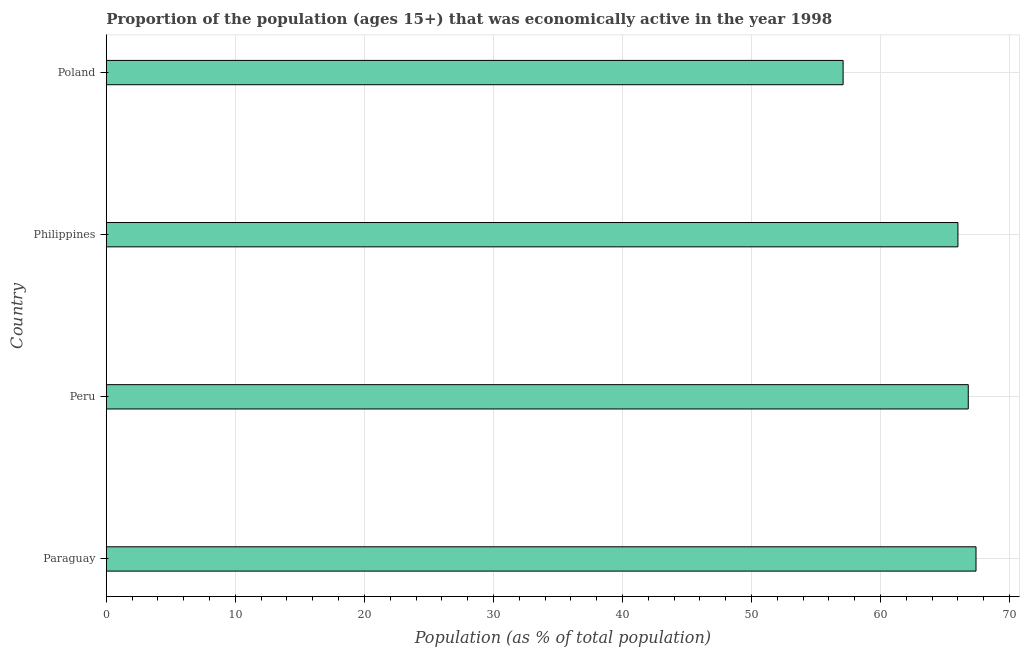Does the graph contain any zero values?
Offer a terse response. No. Does the graph contain grids?
Offer a very short reply. Yes. What is the title of the graph?
Provide a short and direct response. Proportion of the population (ages 15+) that was economically active in the year 1998. What is the label or title of the X-axis?
Offer a very short reply. Population (as % of total population). Across all countries, what is the maximum percentage of economically active population?
Ensure brevity in your answer.  67.4. Across all countries, what is the minimum percentage of economically active population?
Give a very brief answer. 57.1. In which country was the percentage of economically active population maximum?
Ensure brevity in your answer.  Paraguay. What is the sum of the percentage of economically active population?
Offer a terse response. 257.3. What is the average percentage of economically active population per country?
Offer a very short reply. 64.33. What is the median percentage of economically active population?
Your answer should be compact. 66.4. In how many countries, is the percentage of economically active population greater than 62 %?
Give a very brief answer. 3. What is the ratio of the percentage of economically active population in Paraguay to that in Poland?
Give a very brief answer. 1.18. Is the percentage of economically active population in Paraguay less than that in Peru?
Provide a succinct answer. No. Is the difference between the percentage of economically active population in Paraguay and Poland greater than the difference between any two countries?
Provide a short and direct response. Yes. What is the difference between the highest and the second highest percentage of economically active population?
Your response must be concise. 0.6. Is the sum of the percentage of economically active population in Peru and Philippines greater than the maximum percentage of economically active population across all countries?
Provide a succinct answer. Yes. What is the difference between the highest and the lowest percentage of economically active population?
Keep it short and to the point. 10.3. In how many countries, is the percentage of economically active population greater than the average percentage of economically active population taken over all countries?
Give a very brief answer. 3. How many bars are there?
Give a very brief answer. 4. How many countries are there in the graph?
Make the answer very short. 4. What is the difference between two consecutive major ticks on the X-axis?
Provide a succinct answer. 10. Are the values on the major ticks of X-axis written in scientific E-notation?
Your response must be concise. No. What is the Population (as % of total population) in Paraguay?
Keep it short and to the point. 67.4. What is the Population (as % of total population) in Peru?
Your answer should be very brief. 66.8. What is the Population (as % of total population) in Poland?
Provide a succinct answer. 57.1. What is the difference between the Population (as % of total population) in Paraguay and Poland?
Your answer should be very brief. 10.3. What is the difference between the Population (as % of total population) in Peru and Philippines?
Keep it short and to the point. 0.8. What is the difference between the Population (as % of total population) in Peru and Poland?
Your response must be concise. 9.7. What is the difference between the Population (as % of total population) in Philippines and Poland?
Provide a succinct answer. 8.9. What is the ratio of the Population (as % of total population) in Paraguay to that in Peru?
Your answer should be compact. 1.01. What is the ratio of the Population (as % of total population) in Paraguay to that in Poland?
Give a very brief answer. 1.18. What is the ratio of the Population (as % of total population) in Peru to that in Poland?
Your answer should be compact. 1.17. What is the ratio of the Population (as % of total population) in Philippines to that in Poland?
Offer a terse response. 1.16. 